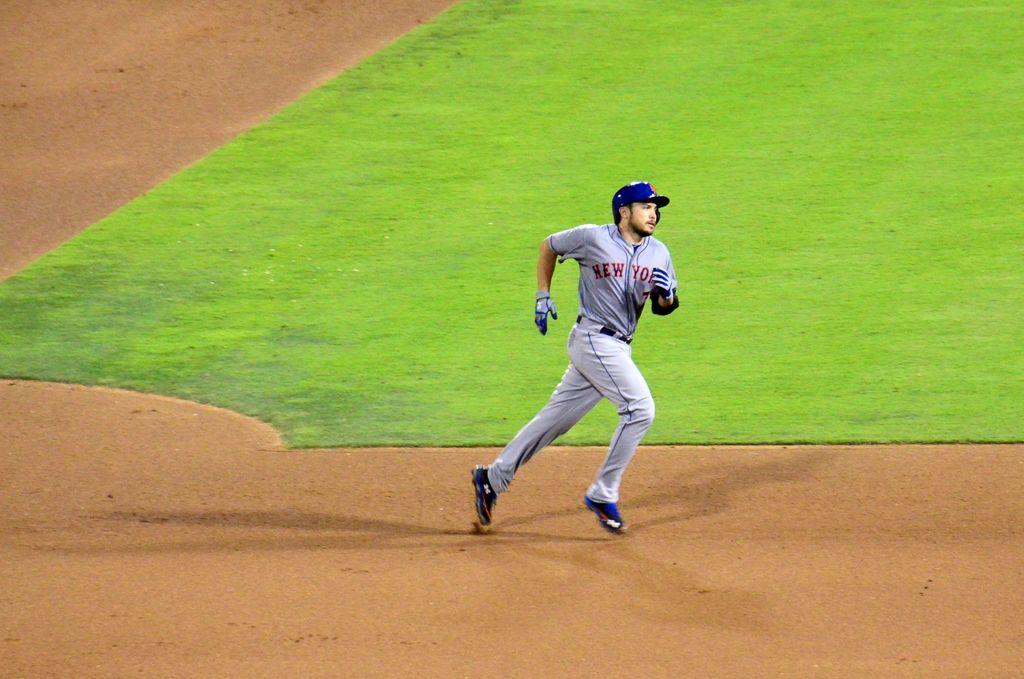What word is on the player's right breast?
Provide a succinct answer. New. 